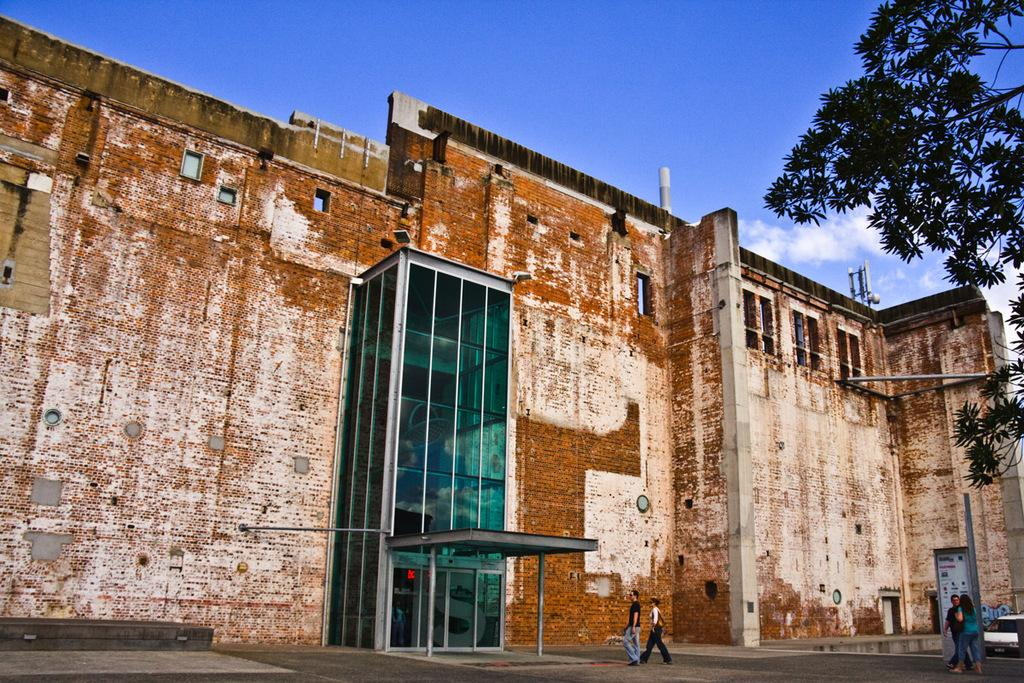What type of structure is present in the image? There is a building in the image. What are the people in the image doing? People are walking on the ground in the image. What else can be seen on the ground in the image? There is a vehicle on the ground in the image. What can be seen in the background of the image? There is a tree, a tower, and other objects visible in the background of the image. What is visible in the sky in the image? The sky is visible in the background of the image. What is the opinion of the door in the image? There is no door present in the image, so it is not possible to determine its opinion. 